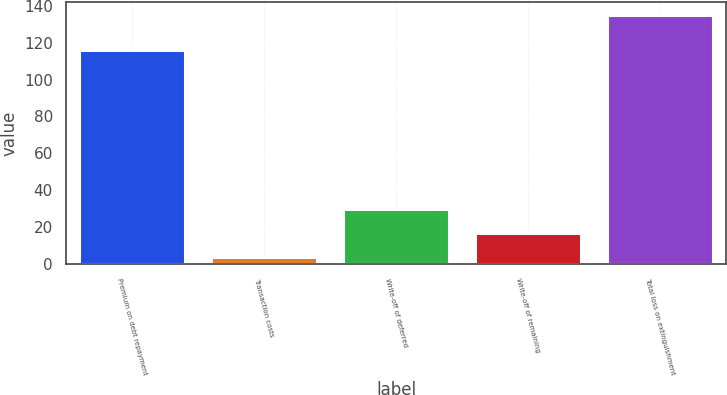Convert chart to OTSL. <chart><loc_0><loc_0><loc_500><loc_500><bar_chart><fcel>Premium on debt repayment<fcel>Transaction costs<fcel>Write-off of deferred<fcel>Write-off of remaining<fcel>Total loss on extinguishment<nl><fcel>116.1<fcel>3.8<fcel>30.08<fcel>16.94<fcel>135.2<nl></chart> 